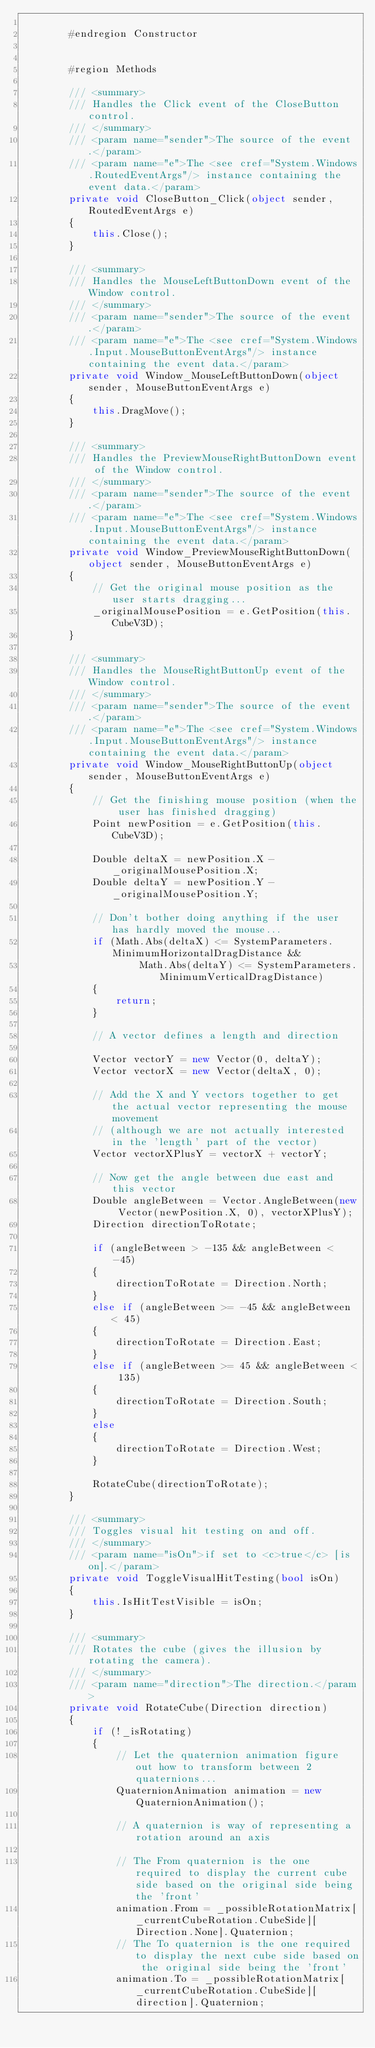Convert code to text. <code><loc_0><loc_0><loc_500><loc_500><_C#_>
        #endregion Constructor


        #region Methods

        /// <summary>
        /// Handles the Click event of the CloseButton control.
        /// </summary>
        /// <param name="sender">The source of the event.</param>
        /// <param name="e">The <see cref="System.Windows.RoutedEventArgs"/> instance containing the event data.</param>
        private void CloseButton_Click(object sender, RoutedEventArgs e)
        {
            this.Close();
        }

        /// <summary>
        /// Handles the MouseLeftButtonDown event of the Window control.
        /// </summary>
        /// <param name="sender">The source of the event.</param>
        /// <param name="e">The <see cref="System.Windows.Input.MouseButtonEventArgs"/> instance containing the event data.</param>
        private void Window_MouseLeftButtonDown(object sender, MouseButtonEventArgs e)
        {
            this.DragMove();
        }

        /// <summary>
        /// Handles the PreviewMouseRightButtonDown event of the Window control.
        /// </summary>
        /// <param name="sender">The source of the event.</param>
        /// <param name="e">The <see cref="System.Windows.Input.MouseButtonEventArgs"/> instance containing the event data.</param>
        private void Window_PreviewMouseRightButtonDown(object sender, MouseButtonEventArgs e)
        {
            // Get the original mouse position as the user starts dragging...
            _originalMousePosition = e.GetPosition(this.CubeV3D);
        }

        /// <summary>
        /// Handles the MouseRightButtonUp event of the Window control.
        /// </summary>
        /// <param name="sender">The source of the event.</param>
        /// <param name="e">The <see cref="System.Windows.Input.MouseButtonEventArgs"/> instance containing the event data.</param>
        private void Window_MouseRightButtonUp(object sender, MouseButtonEventArgs e)
        {
            // Get the finishing mouse position (when the user has finished dragging)
            Point newPosition = e.GetPosition(this.CubeV3D);

            Double deltaX = newPosition.X - _originalMousePosition.X;
            Double deltaY = newPosition.Y - _originalMousePosition.Y;

            // Don't bother doing anything if the user has hardly moved the mouse...
            if (Math.Abs(deltaX) <= SystemParameters.MinimumHorizontalDragDistance &&
                    Math.Abs(deltaY) <= SystemParameters.MinimumVerticalDragDistance)
            {
                return;
            }

            // A vector defines a length and direction

            Vector vectorY = new Vector(0, deltaY);
            Vector vectorX = new Vector(deltaX, 0);

            // Add the X and Y vectors together to get the actual vector representing the mouse movement
            // (although we are not actually interested in the 'length' part of the vector)
            Vector vectorXPlusY = vectorX + vectorY;

            // Now get the angle between due east and this vector
            Double angleBetween = Vector.AngleBetween(new Vector(newPosition.X, 0), vectorXPlusY);
            Direction directionToRotate;

            if (angleBetween > -135 && angleBetween < -45)
            {
                directionToRotate = Direction.North;
            }
            else if (angleBetween >= -45 && angleBetween < 45)
            {
                directionToRotate = Direction.East;
            }
            else if (angleBetween >= 45 && angleBetween < 135)
            {
                directionToRotate = Direction.South;
            }
            else
            {
                directionToRotate = Direction.West;
            }

            RotateCube(directionToRotate);
        }

        /// <summary>
        /// Toggles visual hit testing on and off.
        /// </summary>
        /// <param name="isOn">if set to <c>true</c> [is on].</param>
        private void ToggleVisualHitTesting(bool isOn)
        {
            this.IsHitTestVisible = isOn;
        }

        /// <summary>
        /// Rotates the cube (gives the illusion by rotating the camera).
        /// </summary>
        /// <param name="direction">The direction.</param>
        private void RotateCube(Direction direction)
        {
            if (!_isRotating)
            {
                // Let the quaternion animation figure out how to transform between 2 quaternions...
                QuaternionAnimation animation = new QuaternionAnimation();

                // A quaternion is way of representing a rotation around an axis

                // The From quaternion is the one required to display the current cube side based on the original side being the 'front'  
                animation.From = _possibleRotationMatrix[_currentCubeRotation.CubeSide][Direction.None].Quaternion;
                // The To quaternion is the one required to display the next cube side based on the original side being the 'front'
                animation.To = _possibleRotationMatrix[_currentCubeRotation.CubeSide][direction].Quaternion;</code> 